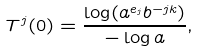Convert formula to latex. <formula><loc_0><loc_0><loc_500><loc_500>T ^ { j } ( 0 ) = \frac { \log ( a ^ { e _ { j } } b ^ { - j k } ) } { - \log a } ,</formula> 